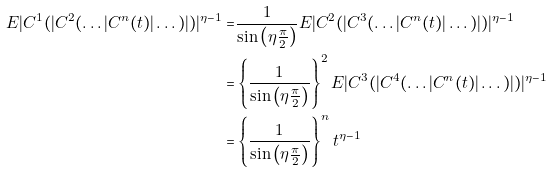<formula> <loc_0><loc_0><loc_500><loc_500>E | C ^ { 1 } ( | C ^ { 2 } ( \dots | C ^ { n } ( t ) | \dots ) | ) | ^ { \eta - 1 } = & \frac { 1 } { \sin \left ( \eta \frac { \pi } { 2 } \right ) } E | C ^ { 2 } ( | C ^ { 3 } ( \dots | C ^ { n } ( t ) | \dots ) | ) | ^ { \eta - 1 } \\ = & \left \{ \frac { 1 } { \sin \left ( \eta \frac { \pi } { 2 } \right ) } \right \} ^ { 2 } E | C ^ { 3 } ( | C ^ { 4 } ( \dots | C ^ { n } ( t ) | \dots ) | ) | ^ { \eta - 1 } \\ = & \left \{ \frac { 1 } { \sin \left ( \eta \frac { \pi } { 2 } \right ) } \right \} ^ { n } t ^ { \eta - 1 }</formula> 